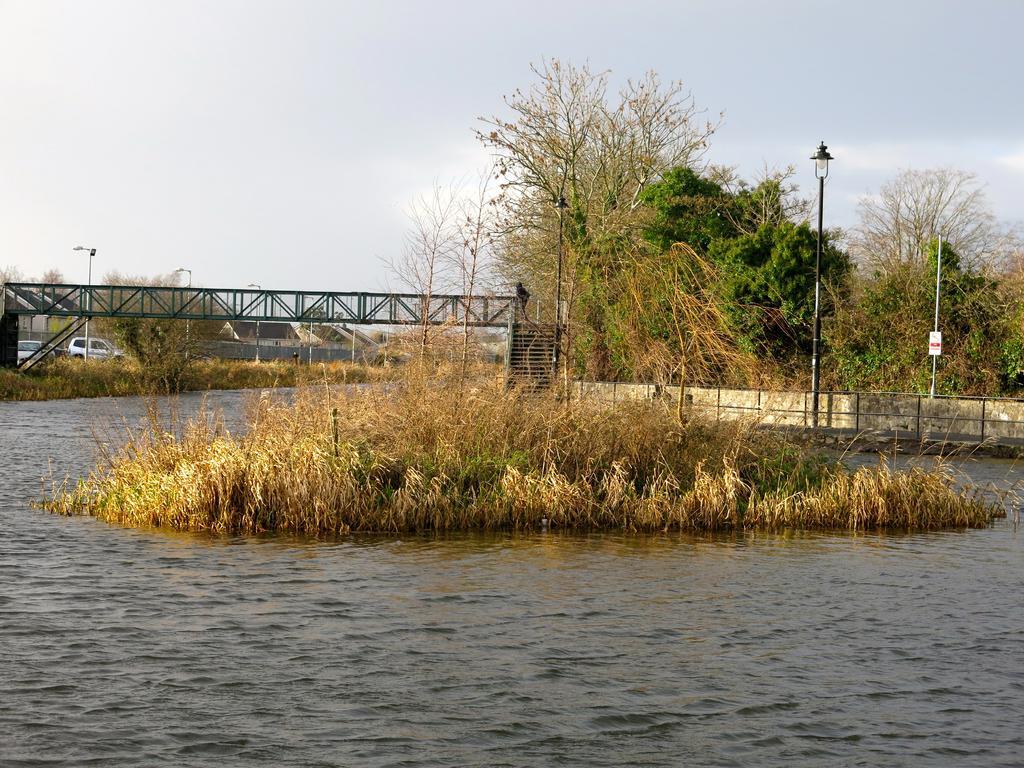Describe this image in one or two sentences. The image is taken at the outdoor. In the center of the image there is a grass. At the bottom there is a river. In the background there are trees, poles, bridge, cars and sky. 